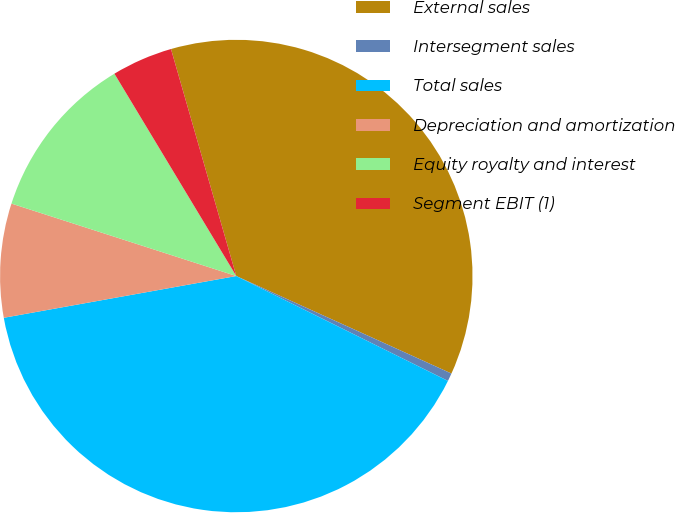Convert chart to OTSL. <chart><loc_0><loc_0><loc_500><loc_500><pie_chart><fcel>External sales<fcel>Intersegment sales<fcel>Total sales<fcel>Depreciation and amortization<fcel>Equity royalty and interest<fcel>Segment EBIT (1)<nl><fcel>36.23%<fcel>0.55%<fcel>39.85%<fcel>7.79%<fcel>11.41%<fcel>4.17%<nl></chart> 